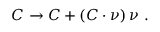Convert formula to latex. <formula><loc_0><loc_0><loc_500><loc_500>C \to C + ( C \cdot \nu ) \, \nu \ .</formula> 